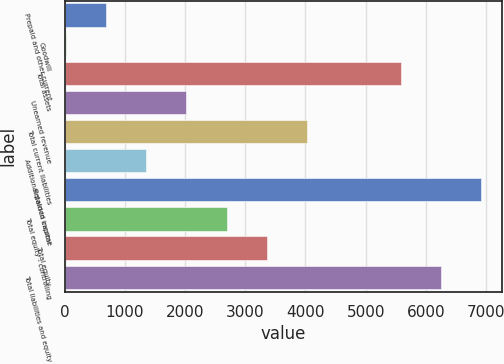<chart> <loc_0><loc_0><loc_500><loc_500><bar_chart><fcel>Prepaid and other current<fcel>Goodwill<fcel>Total assets<fcel>Unearned revenue<fcel>Total current liabilities<fcel>Additional paid-in capital<fcel>Retained income<fcel>Total equity - controlling<fcel>Total equity<fcel>Total liabilities and equity<nl><fcel>685.4<fcel>17<fcel>5582<fcel>2022.2<fcel>4027.4<fcel>1353.8<fcel>6918.8<fcel>2690.6<fcel>3359<fcel>6250.4<nl></chart> 